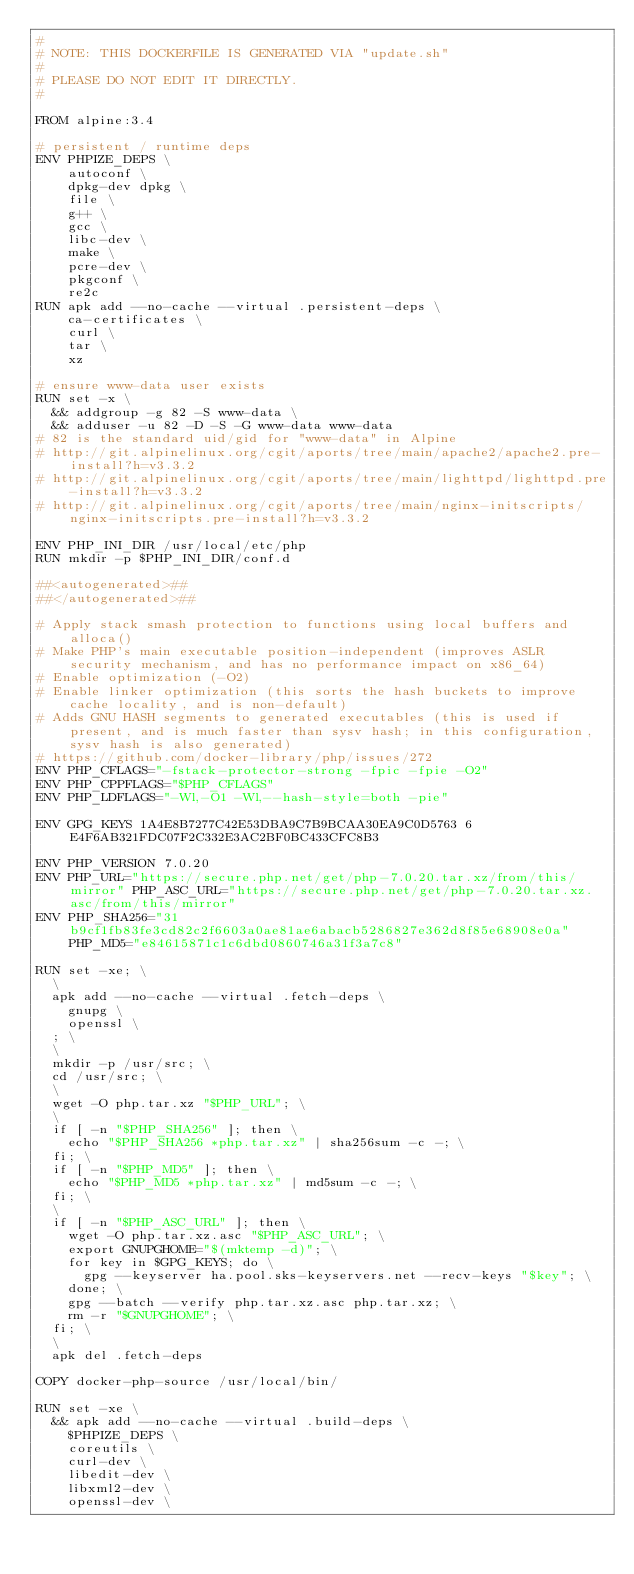<code> <loc_0><loc_0><loc_500><loc_500><_Dockerfile_>#
# NOTE: THIS DOCKERFILE IS GENERATED VIA "update.sh"
#
# PLEASE DO NOT EDIT IT DIRECTLY.
#

FROM alpine:3.4

# persistent / runtime deps
ENV PHPIZE_DEPS \
		autoconf \
		dpkg-dev dpkg \
		file \
		g++ \
		gcc \
		libc-dev \
		make \
		pcre-dev \
		pkgconf \
		re2c
RUN apk add --no-cache --virtual .persistent-deps \
		ca-certificates \
		curl \
		tar \
		xz

# ensure www-data user exists
RUN set -x \
	&& addgroup -g 82 -S www-data \
	&& adduser -u 82 -D -S -G www-data www-data
# 82 is the standard uid/gid for "www-data" in Alpine
# http://git.alpinelinux.org/cgit/aports/tree/main/apache2/apache2.pre-install?h=v3.3.2
# http://git.alpinelinux.org/cgit/aports/tree/main/lighttpd/lighttpd.pre-install?h=v3.3.2
# http://git.alpinelinux.org/cgit/aports/tree/main/nginx-initscripts/nginx-initscripts.pre-install?h=v3.3.2

ENV PHP_INI_DIR /usr/local/etc/php
RUN mkdir -p $PHP_INI_DIR/conf.d

##<autogenerated>##
##</autogenerated>##

# Apply stack smash protection to functions using local buffers and alloca()
# Make PHP's main executable position-independent (improves ASLR security mechanism, and has no performance impact on x86_64)
# Enable optimization (-O2)
# Enable linker optimization (this sorts the hash buckets to improve cache locality, and is non-default)
# Adds GNU HASH segments to generated executables (this is used if present, and is much faster than sysv hash; in this configuration, sysv hash is also generated)
# https://github.com/docker-library/php/issues/272
ENV PHP_CFLAGS="-fstack-protector-strong -fpic -fpie -O2"
ENV PHP_CPPFLAGS="$PHP_CFLAGS"
ENV PHP_LDFLAGS="-Wl,-O1 -Wl,--hash-style=both -pie"

ENV GPG_KEYS 1A4E8B7277C42E53DBA9C7B9BCAA30EA9C0D5763 6E4F6AB321FDC07F2C332E3AC2BF0BC433CFC8B3

ENV PHP_VERSION 7.0.20
ENV PHP_URL="https://secure.php.net/get/php-7.0.20.tar.xz/from/this/mirror" PHP_ASC_URL="https://secure.php.net/get/php-7.0.20.tar.xz.asc/from/this/mirror"
ENV PHP_SHA256="31b9cf1fb83fe3cd82c2f6603a0ae81ae6abacb5286827e362d8f85e68908e0a" PHP_MD5="e84615871c1c6dbd0860746a31f3a7c8"

RUN set -xe; \
	\
	apk add --no-cache --virtual .fetch-deps \
		gnupg \
		openssl \
	; \
	\
	mkdir -p /usr/src; \
	cd /usr/src; \
	\
	wget -O php.tar.xz "$PHP_URL"; \
	\
	if [ -n "$PHP_SHA256" ]; then \
		echo "$PHP_SHA256 *php.tar.xz" | sha256sum -c -; \
	fi; \
	if [ -n "$PHP_MD5" ]; then \
		echo "$PHP_MD5 *php.tar.xz" | md5sum -c -; \
	fi; \
	\
	if [ -n "$PHP_ASC_URL" ]; then \
		wget -O php.tar.xz.asc "$PHP_ASC_URL"; \
		export GNUPGHOME="$(mktemp -d)"; \
		for key in $GPG_KEYS; do \
			gpg --keyserver ha.pool.sks-keyservers.net --recv-keys "$key"; \
		done; \
		gpg --batch --verify php.tar.xz.asc php.tar.xz; \
		rm -r "$GNUPGHOME"; \
	fi; \
	\
	apk del .fetch-deps

COPY docker-php-source /usr/local/bin/

RUN set -xe \
	&& apk add --no-cache --virtual .build-deps \
		$PHPIZE_DEPS \
		coreutils \
		curl-dev \
		libedit-dev \
		libxml2-dev \
		openssl-dev \</code> 